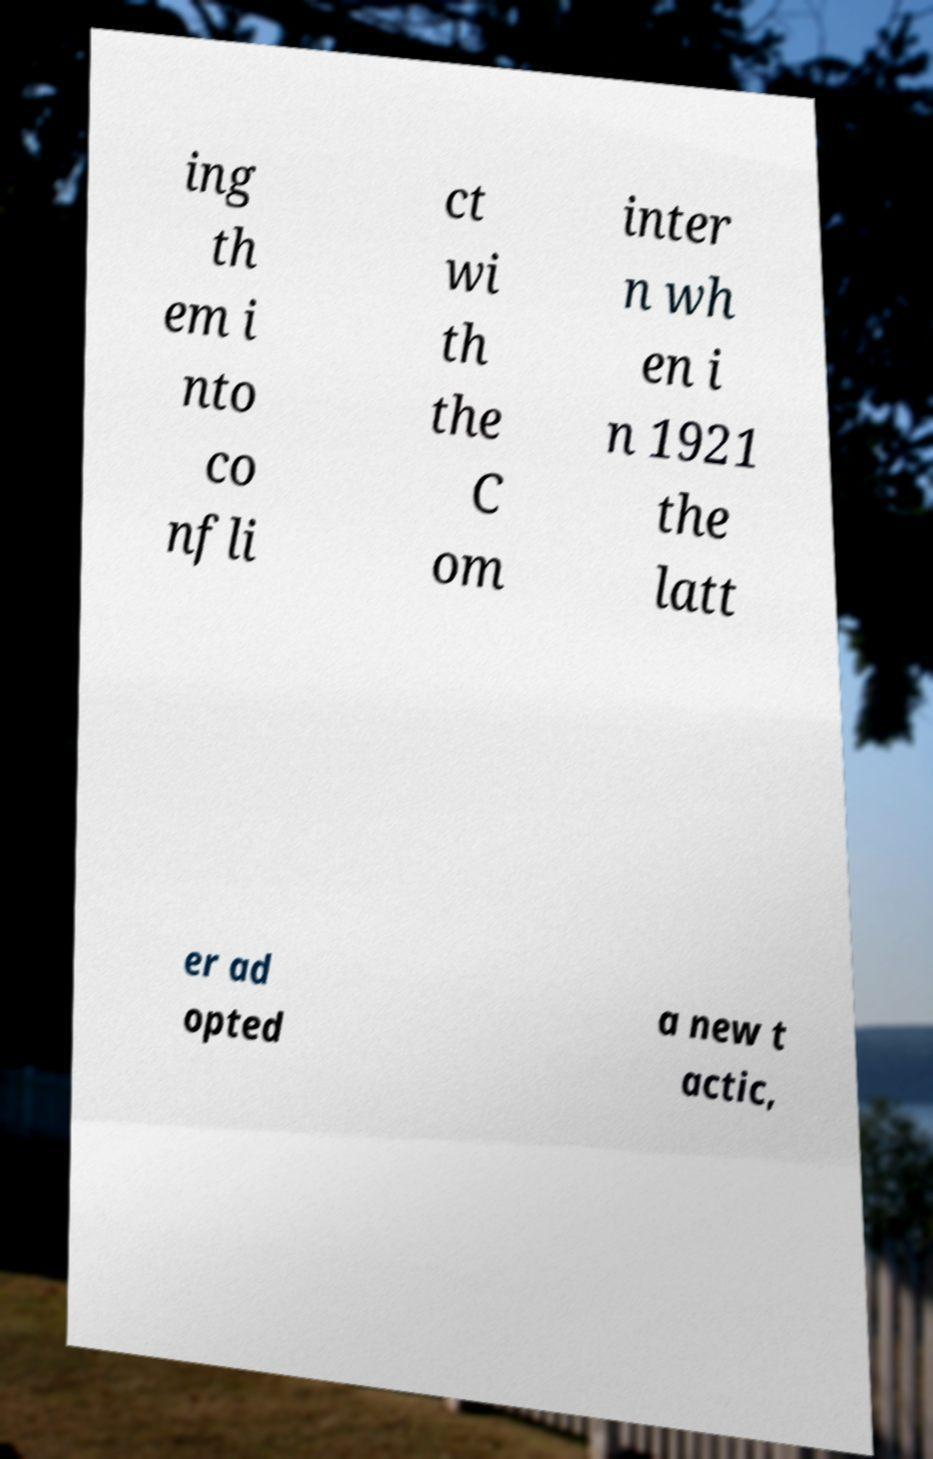Could you extract and type out the text from this image? ing th em i nto co nfli ct wi th the C om inter n wh en i n 1921 the latt er ad opted a new t actic, 